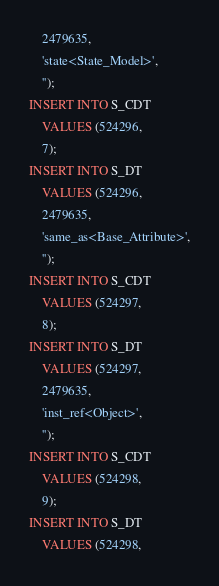Convert code to text. <code><loc_0><loc_0><loc_500><loc_500><_SQL_>	2479635,
	'state<State_Model>',
	'');
INSERT INTO S_CDT
	VALUES (524296,
	7);
INSERT INTO S_DT
	VALUES (524296,
	2479635,
	'same_as<Base_Attribute>',
	'');
INSERT INTO S_CDT
	VALUES (524297,
	8);
INSERT INTO S_DT
	VALUES (524297,
	2479635,
	'inst_ref<Object>',
	'');
INSERT INTO S_CDT
	VALUES (524298,
	9);
INSERT INTO S_DT
	VALUES (524298,</code> 